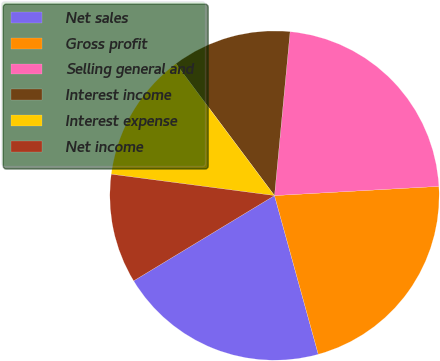<chart> <loc_0><loc_0><loc_500><loc_500><pie_chart><fcel>Net sales<fcel>Gross profit<fcel>Selling general and<fcel>Interest income<fcel>Interest expense<fcel>Net income<nl><fcel>20.62%<fcel>21.61%<fcel>22.6%<fcel>11.73%<fcel>12.71%<fcel>10.74%<nl></chart> 